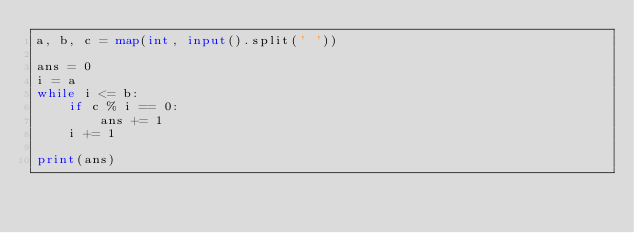<code> <loc_0><loc_0><loc_500><loc_500><_Python_>a, b, c = map(int, input().split(' '))

ans = 0
i = a
while i <= b:
    if c % i == 0:
        ans += 1
    i += 1

print(ans)

</code> 